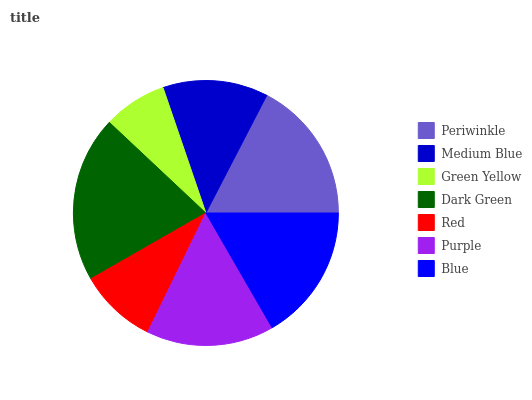Is Green Yellow the minimum?
Answer yes or no. Yes. Is Dark Green the maximum?
Answer yes or no. Yes. Is Medium Blue the minimum?
Answer yes or no. No. Is Medium Blue the maximum?
Answer yes or no. No. Is Periwinkle greater than Medium Blue?
Answer yes or no. Yes. Is Medium Blue less than Periwinkle?
Answer yes or no. Yes. Is Medium Blue greater than Periwinkle?
Answer yes or no. No. Is Periwinkle less than Medium Blue?
Answer yes or no. No. Is Purple the high median?
Answer yes or no. Yes. Is Purple the low median?
Answer yes or no. Yes. Is Blue the high median?
Answer yes or no. No. Is Red the low median?
Answer yes or no. No. 